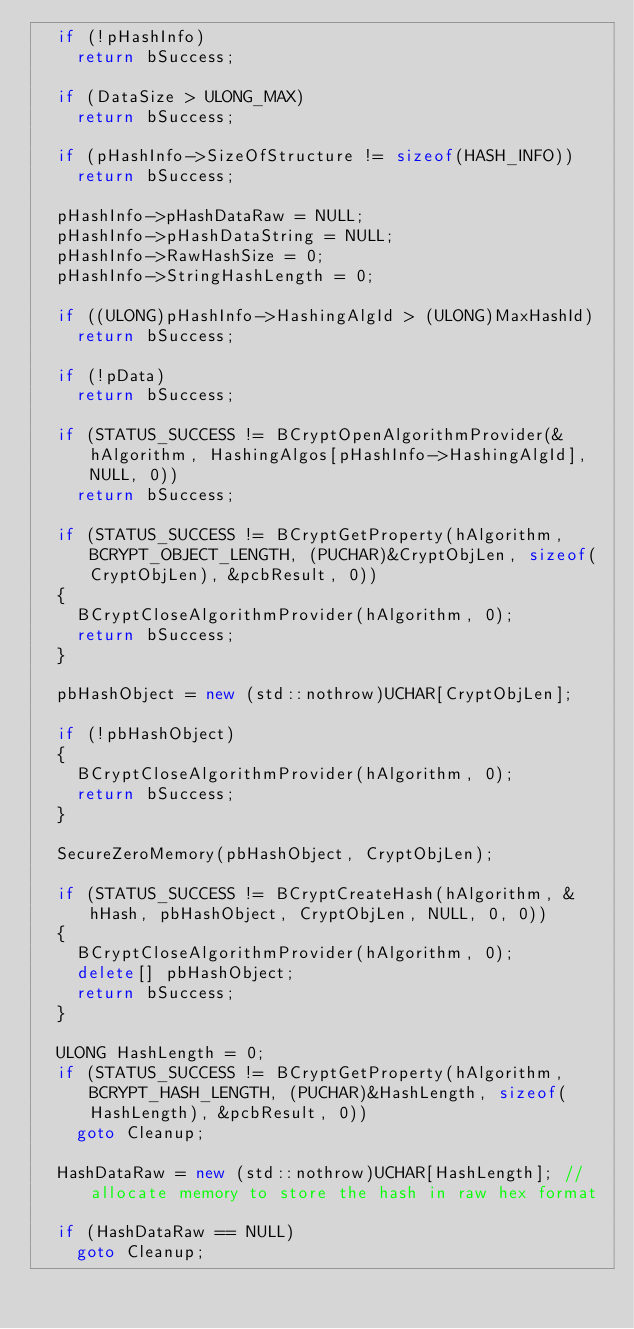Convert code to text. <code><loc_0><loc_0><loc_500><loc_500><_C++_>	if (!pHashInfo)
		return bSuccess;

	if (DataSize > ULONG_MAX)
		return bSuccess;

	if (pHashInfo->SizeOfStructure != sizeof(HASH_INFO))
		return bSuccess;

	pHashInfo->pHashDataRaw = NULL;
	pHashInfo->pHashDataString = NULL;
	pHashInfo->RawHashSize = 0;
	pHashInfo->StringHashLength = 0;

	if ((ULONG)pHashInfo->HashingAlgId > (ULONG)MaxHashId)
		return bSuccess;

	if (!pData)
		return bSuccess;

	if (STATUS_SUCCESS != BCryptOpenAlgorithmProvider(&hAlgorithm, HashingAlgos[pHashInfo->HashingAlgId], NULL, 0))
		return bSuccess;

	if (STATUS_SUCCESS != BCryptGetProperty(hAlgorithm, BCRYPT_OBJECT_LENGTH, (PUCHAR)&CryptObjLen, sizeof(CryptObjLen), &pcbResult, 0))
	{
		BCryptCloseAlgorithmProvider(hAlgorithm, 0);
		return bSuccess;
	}

	pbHashObject = new (std::nothrow)UCHAR[CryptObjLen];

	if (!pbHashObject)
	{
		BCryptCloseAlgorithmProvider(hAlgorithm, 0);
		return bSuccess;
	}

	SecureZeroMemory(pbHashObject, CryptObjLen);

	if (STATUS_SUCCESS != BCryptCreateHash(hAlgorithm, &hHash, pbHashObject, CryptObjLen, NULL, 0, 0))
	{
		BCryptCloseAlgorithmProvider(hAlgorithm, 0);
		delete[] pbHashObject;
		return bSuccess;
	}

	ULONG HashLength = 0;
	if (STATUS_SUCCESS != BCryptGetProperty(hAlgorithm, BCRYPT_HASH_LENGTH, (PUCHAR)&HashLength, sizeof(HashLength), &pcbResult, 0))
		goto Cleanup;

	HashDataRaw = new (std::nothrow)UCHAR[HashLength]; //allocate memory to store the hash in raw hex format

	if (HashDataRaw == NULL)
		goto Cleanup;
</code> 